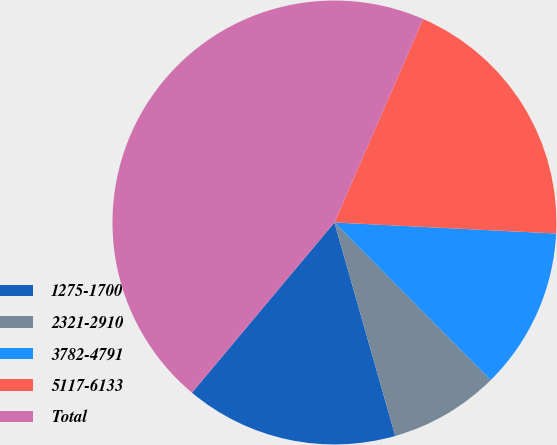Convert chart. <chart><loc_0><loc_0><loc_500><loc_500><pie_chart><fcel>1275-1700<fcel>2321-2910<fcel>3782-4791<fcel>5117-6133<fcel>Total<nl><fcel>15.51%<fcel>8.02%<fcel>11.77%<fcel>19.25%<fcel>45.45%<nl></chart> 